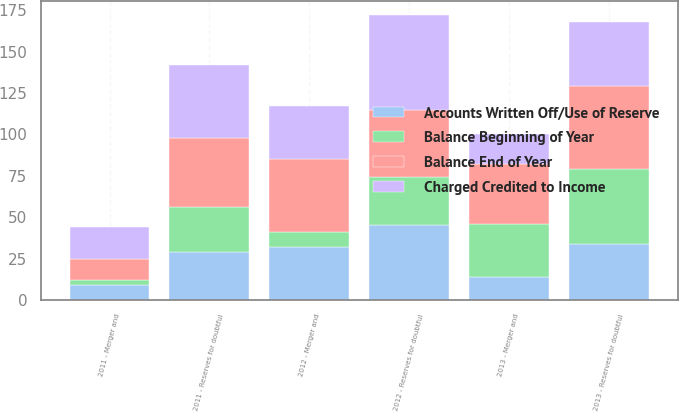Convert chart to OTSL. <chart><loc_0><loc_0><loc_500><loc_500><stacked_bar_chart><ecel><fcel>2011 - Reserves for doubtful<fcel>2012 - Reserves for doubtful<fcel>2013 - Reserves for doubtful<fcel>2011 - Merger and<fcel>2012 - Merger and<fcel>2013 - Merger and<nl><fcel>Balance Beginning of Year<fcel>27<fcel>29<fcel>45<fcel>3<fcel>9<fcel>32<nl><fcel>Charged Credited to Income<fcel>44<fcel>57<fcel>39<fcel>19<fcel>32<fcel>18<nl><fcel>Balance End of Year<fcel>42<fcel>41<fcel>50<fcel>13<fcel>44<fcel>36<nl><fcel>Accounts Written Off/Use of Reserve<fcel>29<fcel>45<fcel>34<fcel>9<fcel>32<fcel>14<nl></chart> 